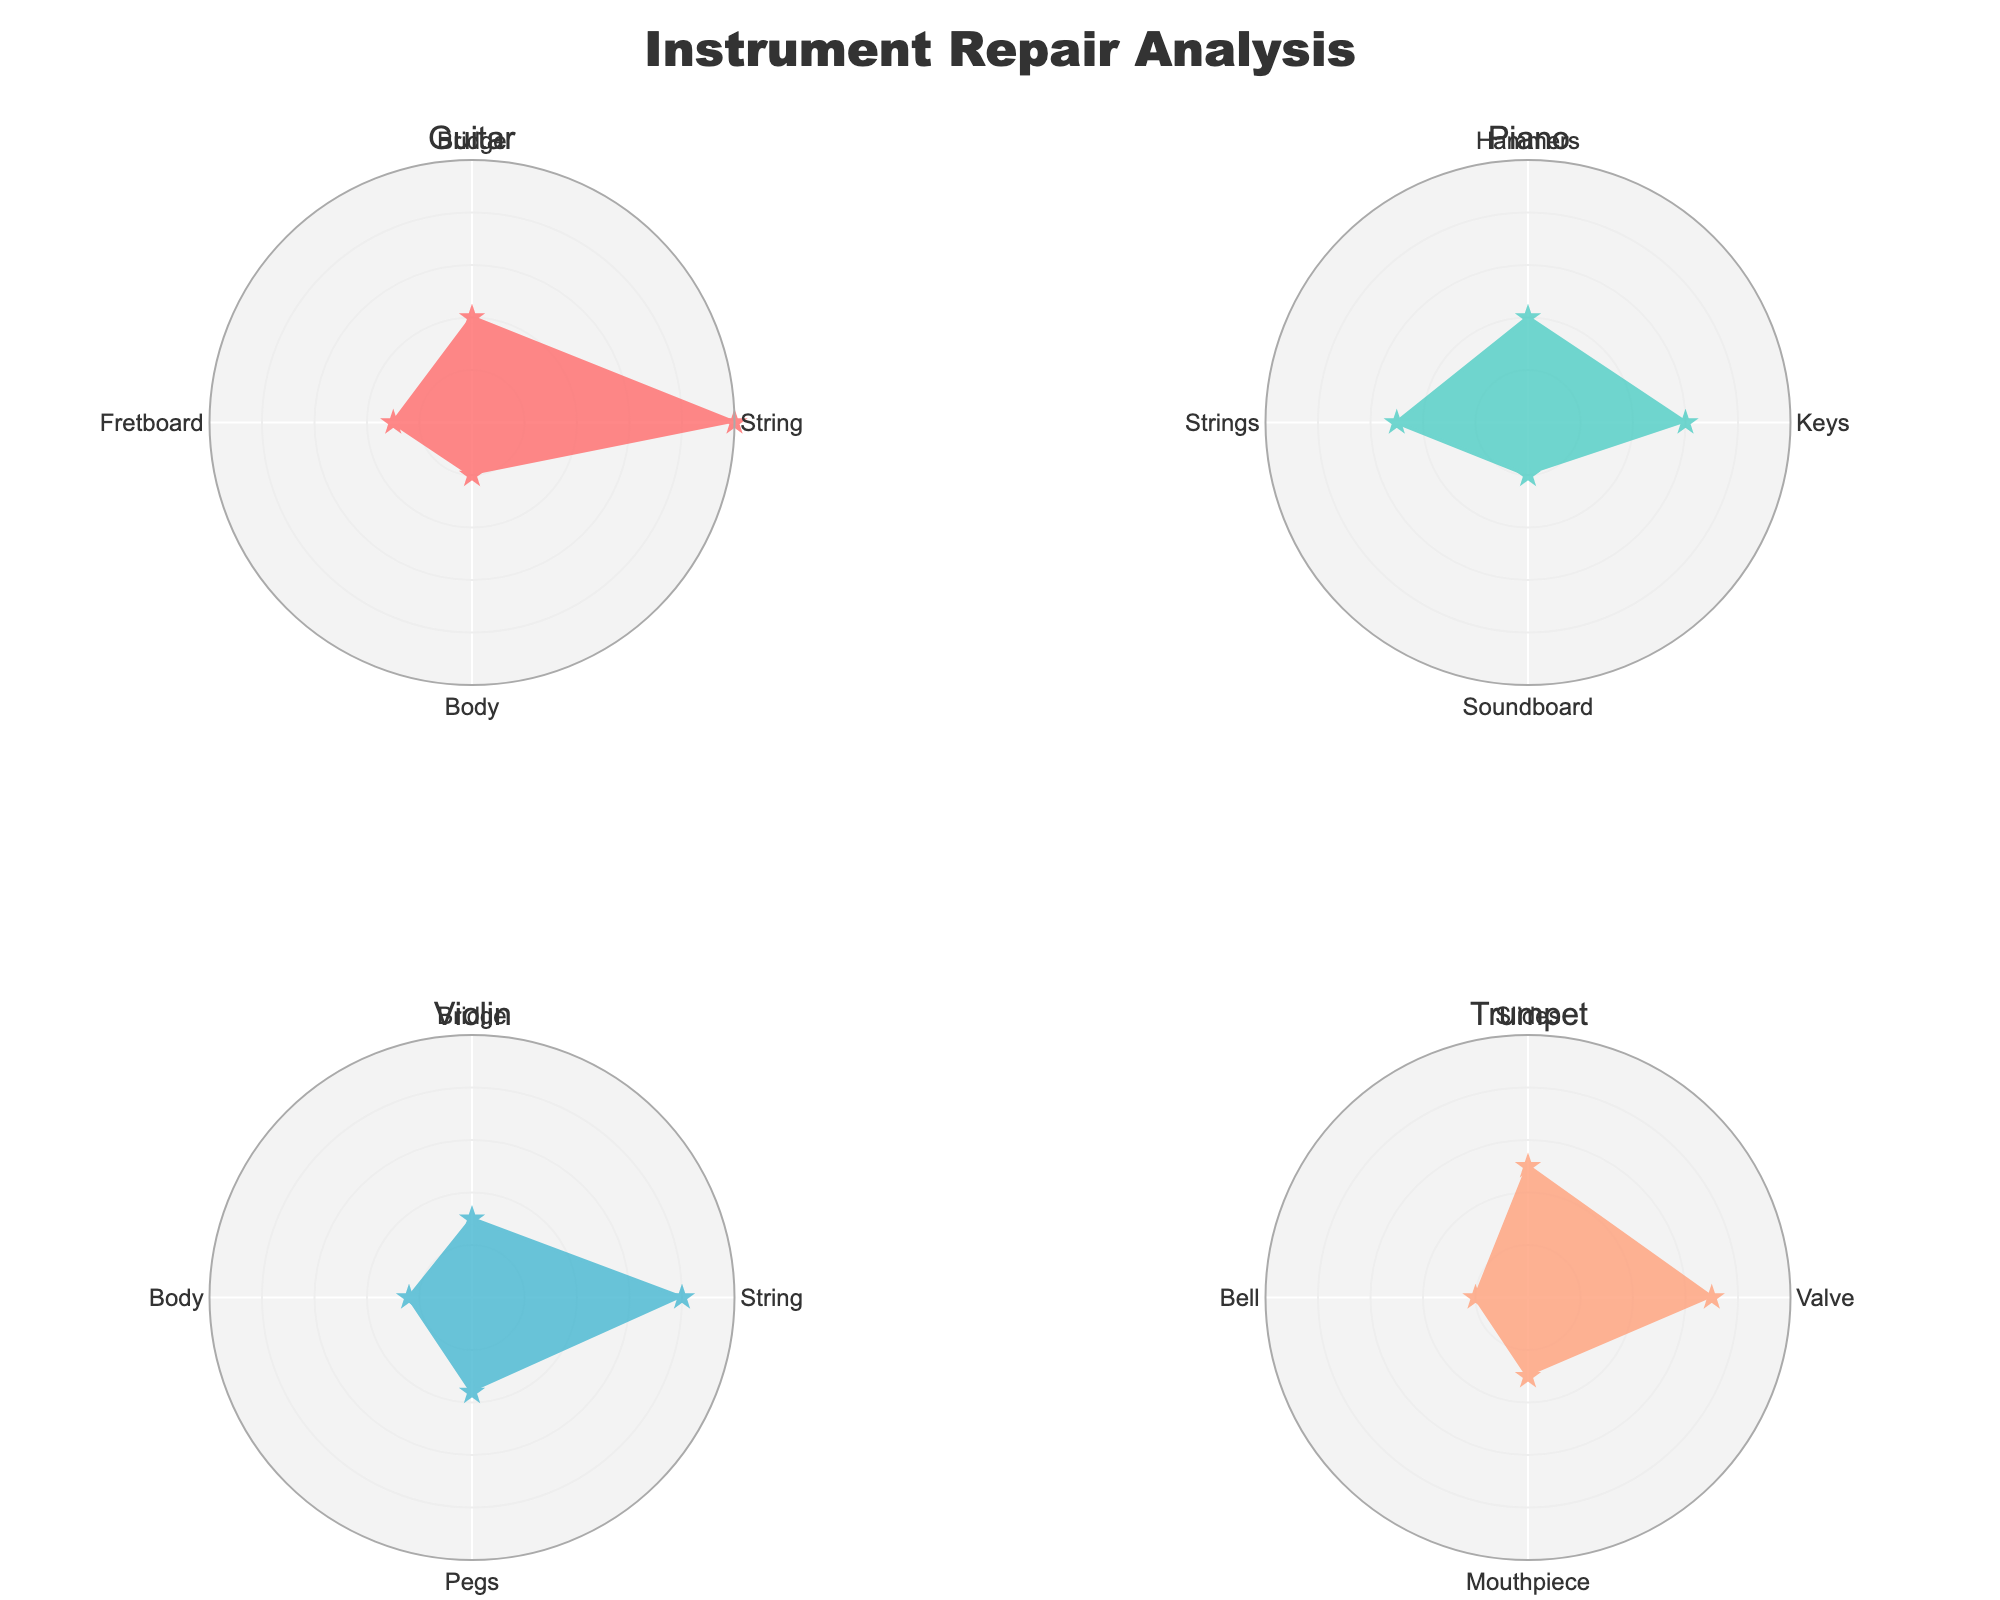Which instrument had the highest number of repairs for a single part? By looking at the plot, note that the Guitar has the highest count for String Replacement, which is 50.
Answer: Guitar Which part of the Violin had the most repairs? In the Violin subplot, the String part has the highest repair count, which is 40.
Answer: String What is the total number of repairs made on the Trumpet? Summing the repair counts for all parts of the Trumpet: 35 (Valve) + 25 (Slides) + 10 (Bell) + 15 (Mouthpiece) = 85
Answer: 85 Are there more repairs made to the Body of the Guitar or the Soundboard of the Piano? The plot shows that the Guitar Body repairs are 10, while the Piano Soundboard repairs are also 10, so they are equal.
Answer: Equal What's the difference between the number of String Replacement repairs on the Guitar and the Violin? The Guitar has 50 String Replacement repairs, and the Violin has 40. The difference is 50 - 40 = 10.
Answer: 10 Which instrument has the most varied parts needing repairs? The plot shows that each instrument has 4 parts displayed, so the variation is the same across instruments.
Answer: Same How does the number of repairs on the Piano's Keys compare to those on the Piano's Strings? The Piano subplot shows that Key Realignment has 30 repairs, and String Tuning has 25 repairs. 30 is greater than 25.
Answer: Keys has more Which type of repair is most commonly performed across all instruments? Looking at all subplots, it is clear that String Replacement for the Guitar has the highest single type count at 50, which indicates it is the most common.
Answer: String Replacement on Guitar What average number of repairs were performed per part on the Violin? Add all repair counts of the Violin parts: 40 (String) + 15 (Bridge) + 12 (Body) + 18 (Pegs) = 85. There are 4 parts, so the average is 85 / 4 = 21.25.
Answer: 21.25 Which part of the Trumpet had the least repairs? The Trumpet subplot shows the Bell had the least repairs with a count of 10.
Answer: Bell 